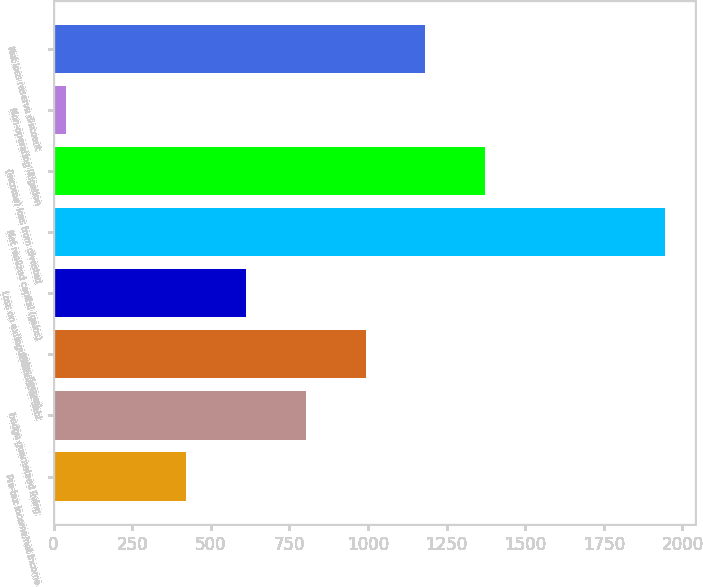<chart> <loc_0><loc_0><loc_500><loc_500><bar_chart><fcel>Pre-tax income/net income<fcel>hedge guaranteed living<fcel>gains (losses)<fcel>Loss on extinguishment of debt<fcel>Net realized capital (gains)<fcel>(Income) loss from divested<fcel>Non-operating litigation<fcel>Net loss reserve discount<nl><fcel>421.6<fcel>802.2<fcel>992.5<fcel>611.9<fcel>1944<fcel>1373.1<fcel>41<fcel>1182.8<nl></chart> 